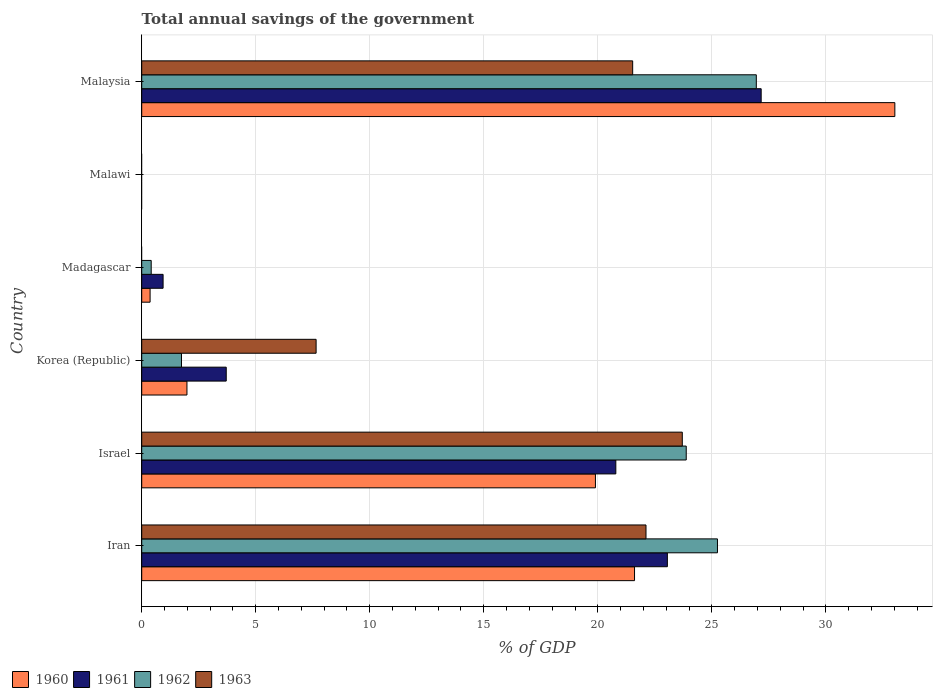How many bars are there on the 1st tick from the bottom?
Your answer should be compact. 4. What is the label of the 2nd group of bars from the top?
Provide a succinct answer. Malawi. In how many cases, is the number of bars for a given country not equal to the number of legend labels?
Offer a terse response. 2. What is the total annual savings of the government in 1962 in Korea (Republic)?
Offer a terse response. 1.74. Across all countries, what is the maximum total annual savings of the government in 1963?
Keep it short and to the point. 23.71. In which country was the total annual savings of the government in 1963 maximum?
Offer a terse response. Israel. What is the total total annual savings of the government in 1961 in the graph?
Give a very brief answer. 75.65. What is the difference between the total annual savings of the government in 1961 in Iran and that in Malaysia?
Offer a very short reply. -4.11. What is the difference between the total annual savings of the government in 1961 in Malaysia and the total annual savings of the government in 1962 in Israel?
Keep it short and to the point. 3.29. What is the average total annual savings of the government in 1962 per country?
Offer a terse response. 13.04. What is the difference between the total annual savings of the government in 1963 and total annual savings of the government in 1960 in Korea (Republic)?
Offer a terse response. 5.66. What is the ratio of the total annual savings of the government in 1962 in Iran to that in Madagascar?
Your response must be concise. 60.69. What is the difference between the highest and the second highest total annual savings of the government in 1961?
Your answer should be very brief. 4.11. What is the difference between the highest and the lowest total annual savings of the government in 1960?
Give a very brief answer. 33.03. In how many countries, is the total annual savings of the government in 1962 greater than the average total annual savings of the government in 1962 taken over all countries?
Provide a succinct answer. 3. Is it the case that in every country, the sum of the total annual savings of the government in 1963 and total annual savings of the government in 1960 is greater than the sum of total annual savings of the government in 1962 and total annual savings of the government in 1961?
Provide a succinct answer. No. Is it the case that in every country, the sum of the total annual savings of the government in 1960 and total annual savings of the government in 1961 is greater than the total annual savings of the government in 1963?
Keep it short and to the point. No. Are all the bars in the graph horizontal?
Make the answer very short. Yes. How many countries are there in the graph?
Your answer should be compact. 6. Are the values on the major ticks of X-axis written in scientific E-notation?
Give a very brief answer. No. Does the graph contain any zero values?
Offer a terse response. Yes. How many legend labels are there?
Your response must be concise. 4. How are the legend labels stacked?
Ensure brevity in your answer.  Horizontal. What is the title of the graph?
Your response must be concise. Total annual savings of the government. What is the label or title of the X-axis?
Offer a very short reply. % of GDP. What is the label or title of the Y-axis?
Offer a terse response. Country. What is the % of GDP of 1960 in Iran?
Your answer should be compact. 21.61. What is the % of GDP of 1961 in Iran?
Give a very brief answer. 23.05. What is the % of GDP of 1962 in Iran?
Make the answer very short. 25.25. What is the % of GDP in 1963 in Iran?
Offer a terse response. 22.11. What is the % of GDP in 1960 in Israel?
Provide a short and direct response. 19.9. What is the % of GDP in 1961 in Israel?
Ensure brevity in your answer.  20.79. What is the % of GDP in 1962 in Israel?
Keep it short and to the point. 23.88. What is the % of GDP in 1963 in Israel?
Ensure brevity in your answer.  23.71. What is the % of GDP in 1960 in Korea (Republic)?
Your response must be concise. 1.98. What is the % of GDP of 1961 in Korea (Republic)?
Offer a very short reply. 3.71. What is the % of GDP in 1962 in Korea (Republic)?
Your answer should be compact. 1.74. What is the % of GDP of 1963 in Korea (Republic)?
Provide a short and direct response. 7.65. What is the % of GDP of 1960 in Madagascar?
Offer a terse response. 0.37. What is the % of GDP in 1961 in Madagascar?
Offer a terse response. 0.94. What is the % of GDP of 1962 in Madagascar?
Ensure brevity in your answer.  0.42. What is the % of GDP in 1963 in Madagascar?
Ensure brevity in your answer.  0. What is the % of GDP in 1960 in Malawi?
Offer a terse response. 0. What is the % of GDP of 1961 in Malawi?
Your response must be concise. 0. What is the % of GDP of 1962 in Malawi?
Your response must be concise. 0. What is the % of GDP of 1960 in Malaysia?
Ensure brevity in your answer.  33.03. What is the % of GDP in 1961 in Malaysia?
Keep it short and to the point. 27.16. What is the % of GDP in 1962 in Malaysia?
Offer a very short reply. 26.95. What is the % of GDP of 1963 in Malaysia?
Your answer should be compact. 21.53. Across all countries, what is the maximum % of GDP of 1960?
Offer a terse response. 33.03. Across all countries, what is the maximum % of GDP of 1961?
Provide a short and direct response. 27.16. Across all countries, what is the maximum % of GDP of 1962?
Provide a short and direct response. 26.95. Across all countries, what is the maximum % of GDP of 1963?
Your answer should be compact. 23.71. Across all countries, what is the minimum % of GDP in 1961?
Provide a succinct answer. 0. Across all countries, what is the minimum % of GDP of 1962?
Keep it short and to the point. 0. What is the total % of GDP in 1960 in the graph?
Ensure brevity in your answer.  76.88. What is the total % of GDP of 1961 in the graph?
Offer a very short reply. 75.65. What is the total % of GDP in 1962 in the graph?
Keep it short and to the point. 78.24. What is the total % of GDP in 1963 in the graph?
Your response must be concise. 74.99. What is the difference between the % of GDP in 1960 in Iran and that in Israel?
Your answer should be very brief. 1.71. What is the difference between the % of GDP in 1961 in Iran and that in Israel?
Give a very brief answer. 2.26. What is the difference between the % of GDP in 1962 in Iran and that in Israel?
Keep it short and to the point. 1.37. What is the difference between the % of GDP in 1963 in Iran and that in Israel?
Give a very brief answer. -1.59. What is the difference between the % of GDP of 1960 in Iran and that in Korea (Republic)?
Give a very brief answer. 19.63. What is the difference between the % of GDP of 1961 in Iran and that in Korea (Republic)?
Your answer should be compact. 19.34. What is the difference between the % of GDP of 1962 in Iran and that in Korea (Republic)?
Offer a terse response. 23.5. What is the difference between the % of GDP of 1963 in Iran and that in Korea (Republic)?
Your response must be concise. 14.47. What is the difference between the % of GDP of 1960 in Iran and that in Madagascar?
Your answer should be very brief. 21.24. What is the difference between the % of GDP in 1961 in Iran and that in Madagascar?
Provide a succinct answer. 22.11. What is the difference between the % of GDP of 1962 in Iran and that in Madagascar?
Give a very brief answer. 24.83. What is the difference between the % of GDP in 1960 in Iran and that in Malaysia?
Offer a very short reply. -11.41. What is the difference between the % of GDP of 1961 in Iran and that in Malaysia?
Offer a very short reply. -4.11. What is the difference between the % of GDP in 1962 in Iran and that in Malaysia?
Ensure brevity in your answer.  -1.7. What is the difference between the % of GDP in 1963 in Iran and that in Malaysia?
Give a very brief answer. 0.58. What is the difference between the % of GDP in 1960 in Israel and that in Korea (Republic)?
Offer a very short reply. 17.91. What is the difference between the % of GDP in 1961 in Israel and that in Korea (Republic)?
Your answer should be very brief. 17.08. What is the difference between the % of GDP in 1962 in Israel and that in Korea (Republic)?
Your answer should be compact. 22.13. What is the difference between the % of GDP in 1963 in Israel and that in Korea (Republic)?
Give a very brief answer. 16.06. What is the difference between the % of GDP in 1960 in Israel and that in Madagascar?
Offer a very short reply. 19.53. What is the difference between the % of GDP in 1961 in Israel and that in Madagascar?
Offer a very short reply. 19.85. What is the difference between the % of GDP in 1962 in Israel and that in Madagascar?
Your response must be concise. 23.46. What is the difference between the % of GDP in 1960 in Israel and that in Malaysia?
Your response must be concise. -13.13. What is the difference between the % of GDP in 1961 in Israel and that in Malaysia?
Offer a very short reply. -6.37. What is the difference between the % of GDP in 1962 in Israel and that in Malaysia?
Give a very brief answer. -3.07. What is the difference between the % of GDP of 1963 in Israel and that in Malaysia?
Keep it short and to the point. 2.18. What is the difference between the % of GDP in 1960 in Korea (Republic) and that in Madagascar?
Give a very brief answer. 1.62. What is the difference between the % of GDP of 1961 in Korea (Republic) and that in Madagascar?
Offer a very short reply. 2.77. What is the difference between the % of GDP in 1962 in Korea (Republic) and that in Madagascar?
Provide a short and direct response. 1.33. What is the difference between the % of GDP in 1960 in Korea (Republic) and that in Malaysia?
Keep it short and to the point. -31.04. What is the difference between the % of GDP in 1961 in Korea (Republic) and that in Malaysia?
Your answer should be compact. -23.46. What is the difference between the % of GDP of 1962 in Korea (Republic) and that in Malaysia?
Keep it short and to the point. -25.21. What is the difference between the % of GDP of 1963 in Korea (Republic) and that in Malaysia?
Keep it short and to the point. -13.88. What is the difference between the % of GDP in 1960 in Madagascar and that in Malaysia?
Your response must be concise. -32.66. What is the difference between the % of GDP in 1961 in Madagascar and that in Malaysia?
Provide a succinct answer. -26.23. What is the difference between the % of GDP of 1962 in Madagascar and that in Malaysia?
Ensure brevity in your answer.  -26.53. What is the difference between the % of GDP in 1960 in Iran and the % of GDP in 1961 in Israel?
Provide a short and direct response. 0.82. What is the difference between the % of GDP in 1960 in Iran and the % of GDP in 1962 in Israel?
Make the answer very short. -2.27. What is the difference between the % of GDP in 1960 in Iran and the % of GDP in 1963 in Israel?
Make the answer very short. -2.09. What is the difference between the % of GDP of 1961 in Iran and the % of GDP of 1962 in Israel?
Your answer should be very brief. -0.83. What is the difference between the % of GDP of 1961 in Iran and the % of GDP of 1963 in Israel?
Your response must be concise. -0.65. What is the difference between the % of GDP in 1962 in Iran and the % of GDP in 1963 in Israel?
Make the answer very short. 1.54. What is the difference between the % of GDP in 1960 in Iran and the % of GDP in 1961 in Korea (Republic)?
Your answer should be very brief. 17.9. What is the difference between the % of GDP in 1960 in Iran and the % of GDP in 1962 in Korea (Republic)?
Keep it short and to the point. 19.87. What is the difference between the % of GDP in 1960 in Iran and the % of GDP in 1963 in Korea (Republic)?
Offer a very short reply. 13.96. What is the difference between the % of GDP of 1961 in Iran and the % of GDP of 1962 in Korea (Republic)?
Make the answer very short. 21.31. What is the difference between the % of GDP of 1961 in Iran and the % of GDP of 1963 in Korea (Republic)?
Provide a succinct answer. 15.4. What is the difference between the % of GDP in 1962 in Iran and the % of GDP in 1963 in Korea (Republic)?
Ensure brevity in your answer.  17.6. What is the difference between the % of GDP in 1960 in Iran and the % of GDP in 1961 in Madagascar?
Your answer should be very brief. 20.67. What is the difference between the % of GDP in 1960 in Iran and the % of GDP in 1962 in Madagascar?
Your answer should be very brief. 21.19. What is the difference between the % of GDP of 1961 in Iran and the % of GDP of 1962 in Madagascar?
Make the answer very short. 22.63. What is the difference between the % of GDP in 1960 in Iran and the % of GDP in 1961 in Malaysia?
Keep it short and to the point. -5.55. What is the difference between the % of GDP in 1960 in Iran and the % of GDP in 1962 in Malaysia?
Your answer should be compact. -5.34. What is the difference between the % of GDP in 1960 in Iran and the % of GDP in 1963 in Malaysia?
Your answer should be compact. 0.08. What is the difference between the % of GDP of 1961 in Iran and the % of GDP of 1962 in Malaysia?
Your answer should be compact. -3.9. What is the difference between the % of GDP of 1961 in Iran and the % of GDP of 1963 in Malaysia?
Offer a very short reply. 1.52. What is the difference between the % of GDP of 1962 in Iran and the % of GDP of 1963 in Malaysia?
Your response must be concise. 3.72. What is the difference between the % of GDP of 1960 in Israel and the % of GDP of 1961 in Korea (Republic)?
Provide a succinct answer. 16.19. What is the difference between the % of GDP of 1960 in Israel and the % of GDP of 1962 in Korea (Republic)?
Make the answer very short. 18.15. What is the difference between the % of GDP of 1960 in Israel and the % of GDP of 1963 in Korea (Republic)?
Make the answer very short. 12.25. What is the difference between the % of GDP of 1961 in Israel and the % of GDP of 1962 in Korea (Republic)?
Provide a succinct answer. 19.05. What is the difference between the % of GDP of 1961 in Israel and the % of GDP of 1963 in Korea (Republic)?
Provide a succinct answer. 13.14. What is the difference between the % of GDP of 1962 in Israel and the % of GDP of 1963 in Korea (Republic)?
Offer a very short reply. 16.23. What is the difference between the % of GDP in 1960 in Israel and the % of GDP in 1961 in Madagascar?
Make the answer very short. 18.96. What is the difference between the % of GDP in 1960 in Israel and the % of GDP in 1962 in Madagascar?
Give a very brief answer. 19.48. What is the difference between the % of GDP of 1961 in Israel and the % of GDP of 1962 in Madagascar?
Provide a succinct answer. 20.37. What is the difference between the % of GDP of 1960 in Israel and the % of GDP of 1961 in Malaysia?
Provide a succinct answer. -7.27. What is the difference between the % of GDP in 1960 in Israel and the % of GDP in 1962 in Malaysia?
Make the answer very short. -7.05. What is the difference between the % of GDP of 1960 in Israel and the % of GDP of 1963 in Malaysia?
Your answer should be compact. -1.63. What is the difference between the % of GDP of 1961 in Israel and the % of GDP of 1962 in Malaysia?
Offer a very short reply. -6.16. What is the difference between the % of GDP in 1961 in Israel and the % of GDP in 1963 in Malaysia?
Offer a very short reply. -0.74. What is the difference between the % of GDP of 1962 in Israel and the % of GDP of 1963 in Malaysia?
Keep it short and to the point. 2.35. What is the difference between the % of GDP of 1960 in Korea (Republic) and the % of GDP of 1961 in Madagascar?
Provide a succinct answer. 1.05. What is the difference between the % of GDP of 1960 in Korea (Republic) and the % of GDP of 1962 in Madagascar?
Make the answer very short. 1.57. What is the difference between the % of GDP in 1961 in Korea (Republic) and the % of GDP in 1962 in Madagascar?
Your answer should be compact. 3.29. What is the difference between the % of GDP in 1960 in Korea (Republic) and the % of GDP in 1961 in Malaysia?
Offer a terse response. -25.18. What is the difference between the % of GDP of 1960 in Korea (Republic) and the % of GDP of 1962 in Malaysia?
Your response must be concise. -24.97. What is the difference between the % of GDP of 1960 in Korea (Republic) and the % of GDP of 1963 in Malaysia?
Your answer should be compact. -19.55. What is the difference between the % of GDP in 1961 in Korea (Republic) and the % of GDP in 1962 in Malaysia?
Offer a very short reply. -23.24. What is the difference between the % of GDP in 1961 in Korea (Republic) and the % of GDP in 1963 in Malaysia?
Offer a terse response. -17.82. What is the difference between the % of GDP of 1962 in Korea (Republic) and the % of GDP of 1963 in Malaysia?
Provide a short and direct response. -19.79. What is the difference between the % of GDP in 1960 in Madagascar and the % of GDP in 1961 in Malaysia?
Offer a terse response. -26.8. What is the difference between the % of GDP of 1960 in Madagascar and the % of GDP of 1962 in Malaysia?
Make the answer very short. -26.58. What is the difference between the % of GDP of 1960 in Madagascar and the % of GDP of 1963 in Malaysia?
Keep it short and to the point. -21.16. What is the difference between the % of GDP in 1961 in Madagascar and the % of GDP in 1962 in Malaysia?
Your response must be concise. -26.01. What is the difference between the % of GDP of 1961 in Madagascar and the % of GDP of 1963 in Malaysia?
Your answer should be very brief. -20.59. What is the difference between the % of GDP in 1962 in Madagascar and the % of GDP in 1963 in Malaysia?
Your answer should be very brief. -21.11. What is the average % of GDP in 1960 per country?
Keep it short and to the point. 12.81. What is the average % of GDP in 1961 per country?
Provide a short and direct response. 12.61. What is the average % of GDP in 1962 per country?
Give a very brief answer. 13.04. What is the average % of GDP of 1963 per country?
Give a very brief answer. 12.5. What is the difference between the % of GDP of 1960 and % of GDP of 1961 in Iran?
Ensure brevity in your answer.  -1.44. What is the difference between the % of GDP in 1960 and % of GDP in 1962 in Iran?
Offer a very short reply. -3.64. What is the difference between the % of GDP of 1960 and % of GDP of 1963 in Iran?
Keep it short and to the point. -0.5. What is the difference between the % of GDP of 1961 and % of GDP of 1962 in Iran?
Make the answer very short. -2.2. What is the difference between the % of GDP of 1961 and % of GDP of 1963 in Iran?
Ensure brevity in your answer.  0.94. What is the difference between the % of GDP of 1962 and % of GDP of 1963 in Iran?
Keep it short and to the point. 3.13. What is the difference between the % of GDP of 1960 and % of GDP of 1961 in Israel?
Your answer should be very brief. -0.89. What is the difference between the % of GDP of 1960 and % of GDP of 1962 in Israel?
Provide a succinct answer. -3.98. What is the difference between the % of GDP of 1960 and % of GDP of 1963 in Israel?
Give a very brief answer. -3.81. What is the difference between the % of GDP of 1961 and % of GDP of 1962 in Israel?
Keep it short and to the point. -3.09. What is the difference between the % of GDP of 1961 and % of GDP of 1963 in Israel?
Your answer should be very brief. -2.91. What is the difference between the % of GDP of 1962 and % of GDP of 1963 in Israel?
Make the answer very short. 0.17. What is the difference between the % of GDP of 1960 and % of GDP of 1961 in Korea (Republic)?
Ensure brevity in your answer.  -1.72. What is the difference between the % of GDP in 1960 and % of GDP in 1962 in Korea (Republic)?
Offer a very short reply. 0.24. What is the difference between the % of GDP of 1960 and % of GDP of 1963 in Korea (Republic)?
Your answer should be compact. -5.66. What is the difference between the % of GDP in 1961 and % of GDP in 1962 in Korea (Republic)?
Your response must be concise. 1.96. What is the difference between the % of GDP of 1961 and % of GDP of 1963 in Korea (Republic)?
Offer a very short reply. -3.94. What is the difference between the % of GDP in 1962 and % of GDP in 1963 in Korea (Republic)?
Provide a short and direct response. -5.9. What is the difference between the % of GDP of 1960 and % of GDP of 1961 in Madagascar?
Offer a terse response. -0.57. What is the difference between the % of GDP of 1960 and % of GDP of 1962 in Madagascar?
Provide a short and direct response. -0.05. What is the difference between the % of GDP of 1961 and % of GDP of 1962 in Madagascar?
Provide a succinct answer. 0.52. What is the difference between the % of GDP in 1960 and % of GDP in 1961 in Malaysia?
Provide a succinct answer. 5.86. What is the difference between the % of GDP of 1960 and % of GDP of 1962 in Malaysia?
Make the answer very short. 6.07. What is the difference between the % of GDP in 1960 and % of GDP in 1963 in Malaysia?
Offer a terse response. 11.5. What is the difference between the % of GDP in 1961 and % of GDP in 1962 in Malaysia?
Your response must be concise. 0.21. What is the difference between the % of GDP in 1961 and % of GDP in 1963 in Malaysia?
Give a very brief answer. 5.63. What is the difference between the % of GDP in 1962 and % of GDP in 1963 in Malaysia?
Your answer should be compact. 5.42. What is the ratio of the % of GDP in 1960 in Iran to that in Israel?
Your response must be concise. 1.09. What is the ratio of the % of GDP in 1961 in Iran to that in Israel?
Provide a succinct answer. 1.11. What is the ratio of the % of GDP of 1962 in Iran to that in Israel?
Provide a short and direct response. 1.06. What is the ratio of the % of GDP of 1963 in Iran to that in Israel?
Make the answer very short. 0.93. What is the ratio of the % of GDP of 1960 in Iran to that in Korea (Republic)?
Offer a terse response. 10.89. What is the ratio of the % of GDP in 1961 in Iran to that in Korea (Republic)?
Your response must be concise. 6.22. What is the ratio of the % of GDP in 1962 in Iran to that in Korea (Republic)?
Keep it short and to the point. 14.48. What is the ratio of the % of GDP of 1963 in Iran to that in Korea (Republic)?
Make the answer very short. 2.89. What is the ratio of the % of GDP of 1960 in Iran to that in Madagascar?
Ensure brevity in your answer.  58.88. What is the ratio of the % of GDP in 1961 in Iran to that in Madagascar?
Your answer should be very brief. 24.6. What is the ratio of the % of GDP of 1962 in Iran to that in Madagascar?
Keep it short and to the point. 60.69. What is the ratio of the % of GDP in 1960 in Iran to that in Malaysia?
Your response must be concise. 0.65. What is the ratio of the % of GDP in 1961 in Iran to that in Malaysia?
Your response must be concise. 0.85. What is the ratio of the % of GDP of 1962 in Iran to that in Malaysia?
Your response must be concise. 0.94. What is the ratio of the % of GDP in 1963 in Iran to that in Malaysia?
Provide a short and direct response. 1.03. What is the ratio of the % of GDP in 1960 in Israel to that in Korea (Republic)?
Provide a short and direct response. 10.03. What is the ratio of the % of GDP in 1961 in Israel to that in Korea (Republic)?
Your answer should be compact. 5.61. What is the ratio of the % of GDP of 1962 in Israel to that in Korea (Republic)?
Keep it short and to the point. 13.69. What is the ratio of the % of GDP in 1963 in Israel to that in Korea (Republic)?
Give a very brief answer. 3.1. What is the ratio of the % of GDP of 1960 in Israel to that in Madagascar?
Offer a terse response. 54.21. What is the ratio of the % of GDP in 1961 in Israel to that in Madagascar?
Keep it short and to the point. 22.19. What is the ratio of the % of GDP in 1962 in Israel to that in Madagascar?
Keep it short and to the point. 57.4. What is the ratio of the % of GDP in 1960 in Israel to that in Malaysia?
Give a very brief answer. 0.6. What is the ratio of the % of GDP in 1961 in Israel to that in Malaysia?
Ensure brevity in your answer.  0.77. What is the ratio of the % of GDP in 1962 in Israel to that in Malaysia?
Keep it short and to the point. 0.89. What is the ratio of the % of GDP in 1963 in Israel to that in Malaysia?
Make the answer very short. 1.1. What is the ratio of the % of GDP of 1960 in Korea (Republic) to that in Madagascar?
Offer a very short reply. 5.4. What is the ratio of the % of GDP of 1961 in Korea (Republic) to that in Madagascar?
Provide a succinct answer. 3.96. What is the ratio of the % of GDP of 1962 in Korea (Republic) to that in Madagascar?
Your answer should be compact. 4.19. What is the ratio of the % of GDP of 1960 in Korea (Republic) to that in Malaysia?
Your answer should be very brief. 0.06. What is the ratio of the % of GDP of 1961 in Korea (Republic) to that in Malaysia?
Offer a terse response. 0.14. What is the ratio of the % of GDP of 1962 in Korea (Republic) to that in Malaysia?
Keep it short and to the point. 0.06. What is the ratio of the % of GDP of 1963 in Korea (Republic) to that in Malaysia?
Give a very brief answer. 0.36. What is the ratio of the % of GDP in 1960 in Madagascar to that in Malaysia?
Your response must be concise. 0.01. What is the ratio of the % of GDP of 1961 in Madagascar to that in Malaysia?
Offer a terse response. 0.03. What is the ratio of the % of GDP of 1962 in Madagascar to that in Malaysia?
Ensure brevity in your answer.  0.02. What is the difference between the highest and the second highest % of GDP of 1960?
Make the answer very short. 11.41. What is the difference between the highest and the second highest % of GDP in 1961?
Make the answer very short. 4.11. What is the difference between the highest and the second highest % of GDP in 1962?
Ensure brevity in your answer.  1.7. What is the difference between the highest and the second highest % of GDP in 1963?
Your response must be concise. 1.59. What is the difference between the highest and the lowest % of GDP in 1960?
Your response must be concise. 33.03. What is the difference between the highest and the lowest % of GDP of 1961?
Your response must be concise. 27.16. What is the difference between the highest and the lowest % of GDP of 1962?
Ensure brevity in your answer.  26.95. What is the difference between the highest and the lowest % of GDP of 1963?
Ensure brevity in your answer.  23.7. 